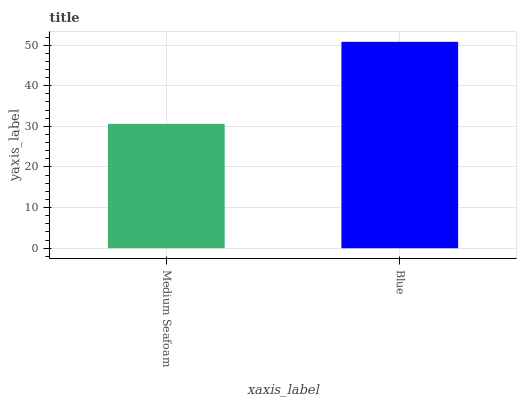Is Medium Seafoam the minimum?
Answer yes or no. Yes. Is Blue the maximum?
Answer yes or no. Yes. Is Blue the minimum?
Answer yes or no. No. Is Blue greater than Medium Seafoam?
Answer yes or no. Yes. Is Medium Seafoam less than Blue?
Answer yes or no. Yes. Is Medium Seafoam greater than Blue?
Answer yes or no. No. Is Blue less than Medium Seafoam?
Answer yes or no. No. Is Blue the high median?
Answer yes or no. Yes. Is Medium Seafoam the low median?
Answer yes or no. Yes. Is Medium Seafoam the high median?
Answer yes or no. No. Is Blue the low median?
Answer yes or no. No. 